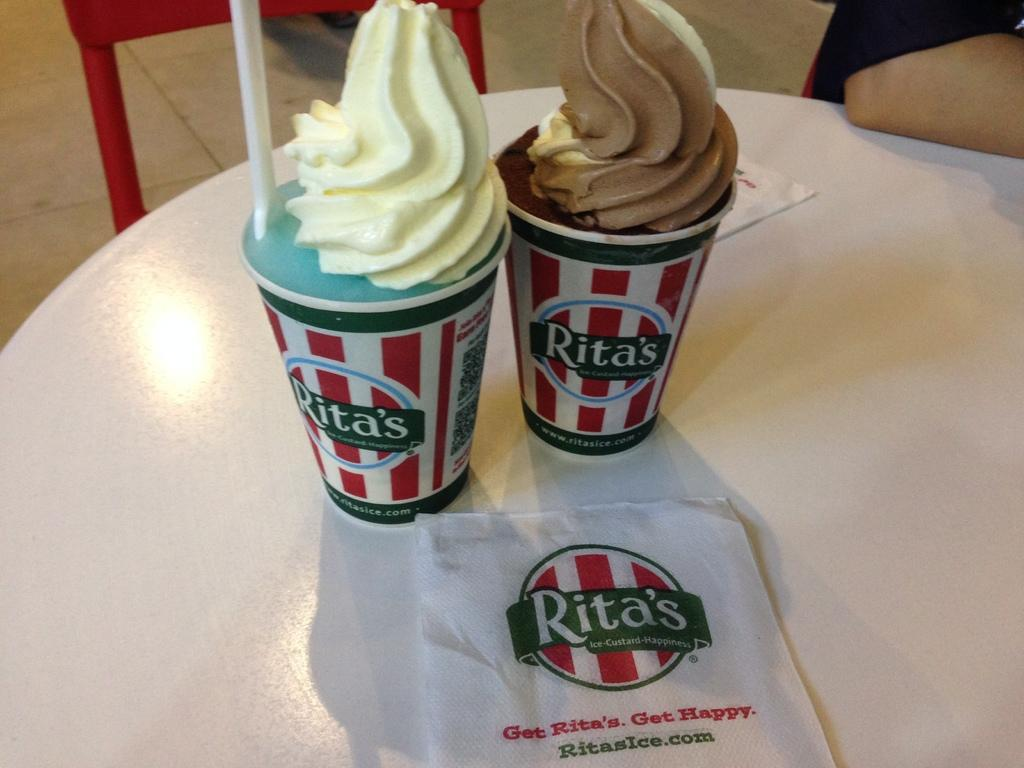What type of food is present in the cups in the image? There are ice cream cups in the image. What items might be used for cleaning or wiping in the image? Napkins are present in the image for cleaning or wiping. Whose hand is visible in the image? A person's hand is visible in the image. What type of furniture can be seen in the background of the image? There is a chair in the background of the image. What surface is visible beneath the ice cream cups and napkins? The floor is visible in the image. How does the snow twist around the ice cream cups in the image? There is no snow present in the image, and therefore no such twisting can be observed. 